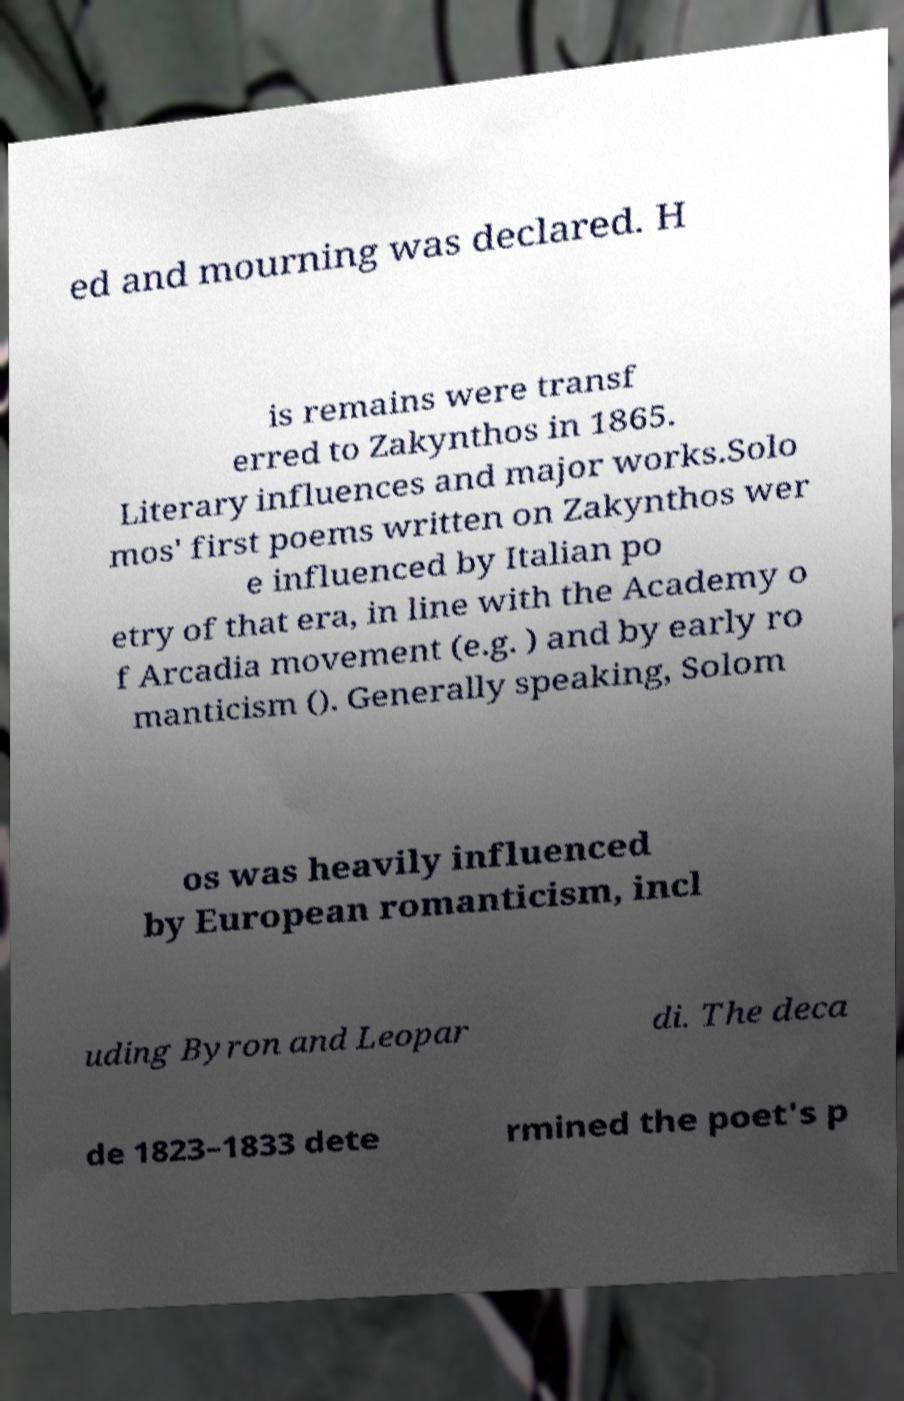Can you accurately transcribe the text from the provided image for me? ed and mourning was declared. H is remains were transf erred to Zakynthos in 1865. Literary influences and major works.Solo mos' first poems written on Zakynthos wer e influenced by Italian po etry of that era, in line with the Academy o f Arcadia movement (e.g. ) and by early ro manticism (). Generally speaking, Solom os was heavily influenced by European romanticism, incl uding Byron and Leopar di. The deca de 1823–1833 dete rmined the poet's p 